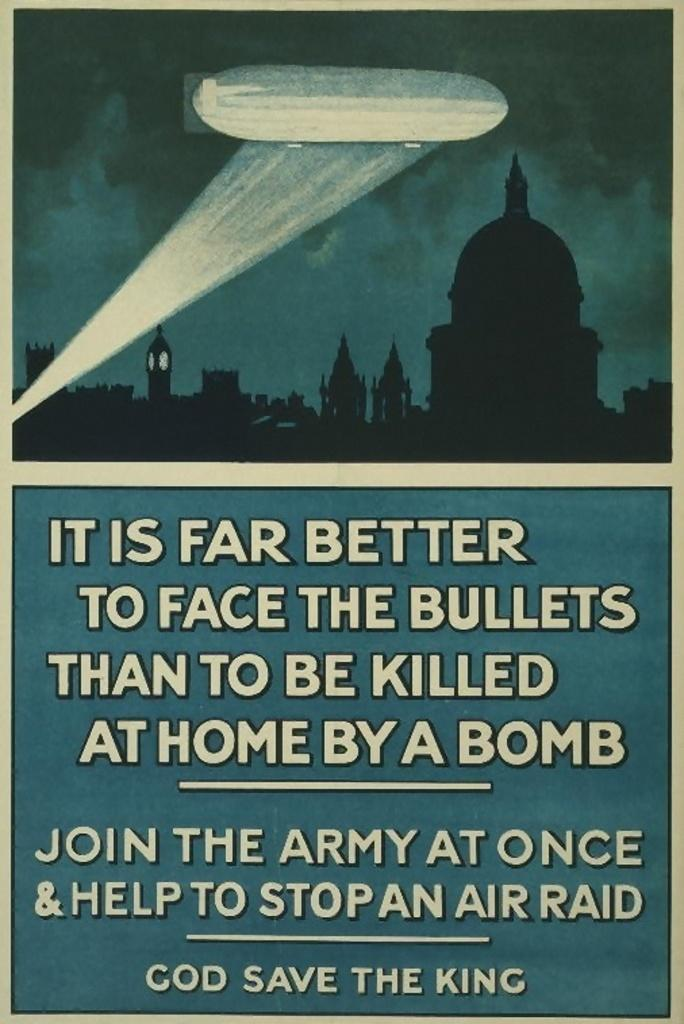<image>
Give a short and clear explanation of the subsequent image. A vintage advertisement to join the army states that it's better "to face the bullets". 